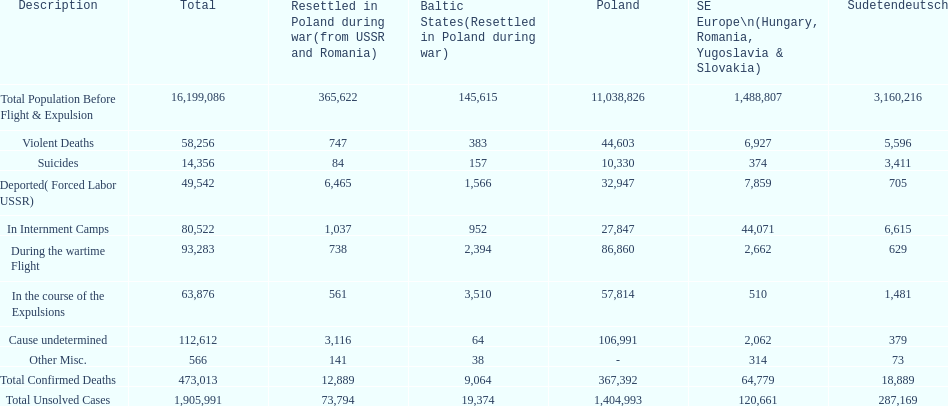Was there a larger total population before expulsion in poland or sudetendeutsch? Poland. 